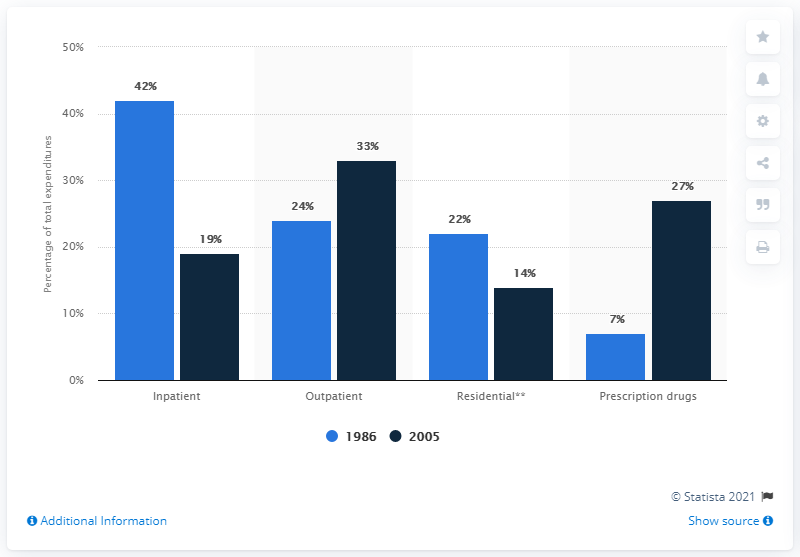Specify some key components in this picture. The sum of the top two blue bars is 66. The light blue bar represents the year 1986. 